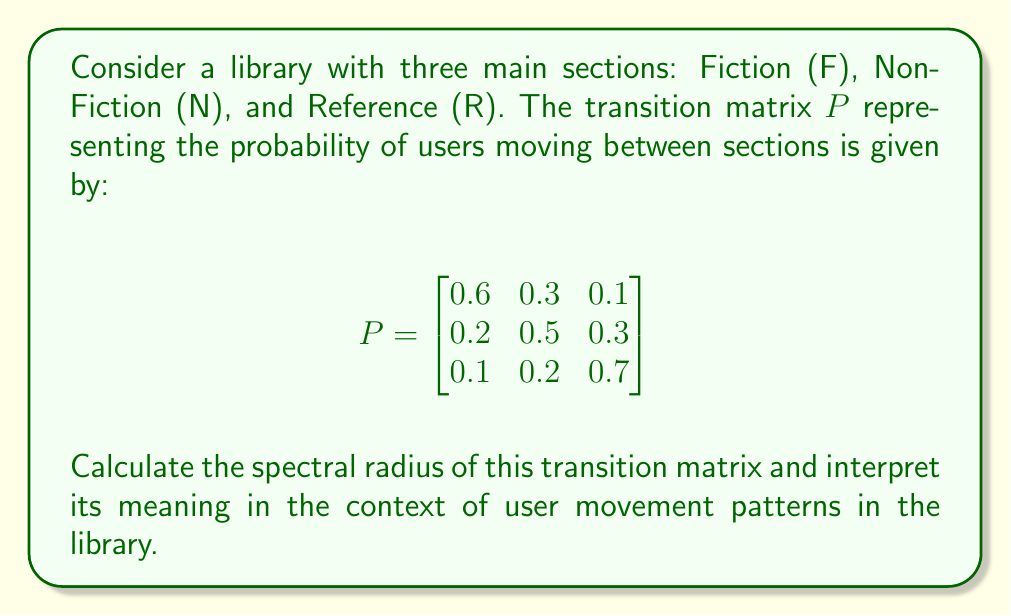Can you answer this question? To find the spectral radius of the transition matrix $P$, we follow these steps:

1) The spectral radius is the largest absolute value of the eigenvalues of $P$. So, we need to find the eigenvalues first.

2) To find the eigenvalues, we solve the characteristic equation:
   $\det(P - \lambda I) = 0$

3) Expanding this determinant:
   $$\begin{vmatrix}
   0.6-\lambda & 0.3 & 0.1 \\
   0.2 & 0.5-\lambda & 0.3 \\
   0.1 & 0.2 & 0.7-\lambda
   \end{vmatrix} = 0$$

4) This yields the characteristic polynomial:
   $-\lambda^3 + 1.8\lambda^2 - 0.97\lambda + 0.16 = 0$

5) Solving this equation (using a computer algebra system or numerical methods) gives us the eigenvalues:
   $\lambda_1 = 1$, $\lambda_2 \approx 0.4539$, $\lambda_3 \approx 0.3461$

6) The spectral radius is the largest absolute value among these eigenvalues, which is 1.

7) Interpretation: The spectral radius of 1 indicates that the Markov chain represented by this transition matrix is regular and has a unique stationary distribution. In the context of the library, this means that over time, the proportion of users in each section will converge to a stable distribution, regardless of the initial distribution.

8) The fact that the spectral radius is exactly 1 is a property of all stochastic matrices (transition matrices where each row sums to 1), which represents conservation of probability in the system.
Answer: 1 